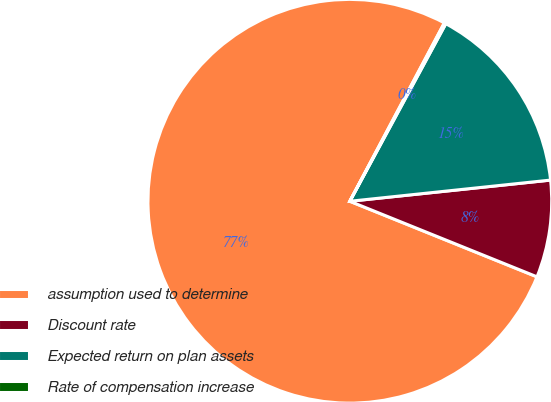Convert chart to OTSL. <chart><loc_0><loc_0><loc_500><loc_500><pie_chart><fcel>assumption used to determine<fcel>Discount rate<fcel>Expected return on plan assets<fcel>Rate of compensation increase<nl><fcel>76.65%<fcel>7.78%<fcel>15.44%<fcel>0.13%<nl></chart> 